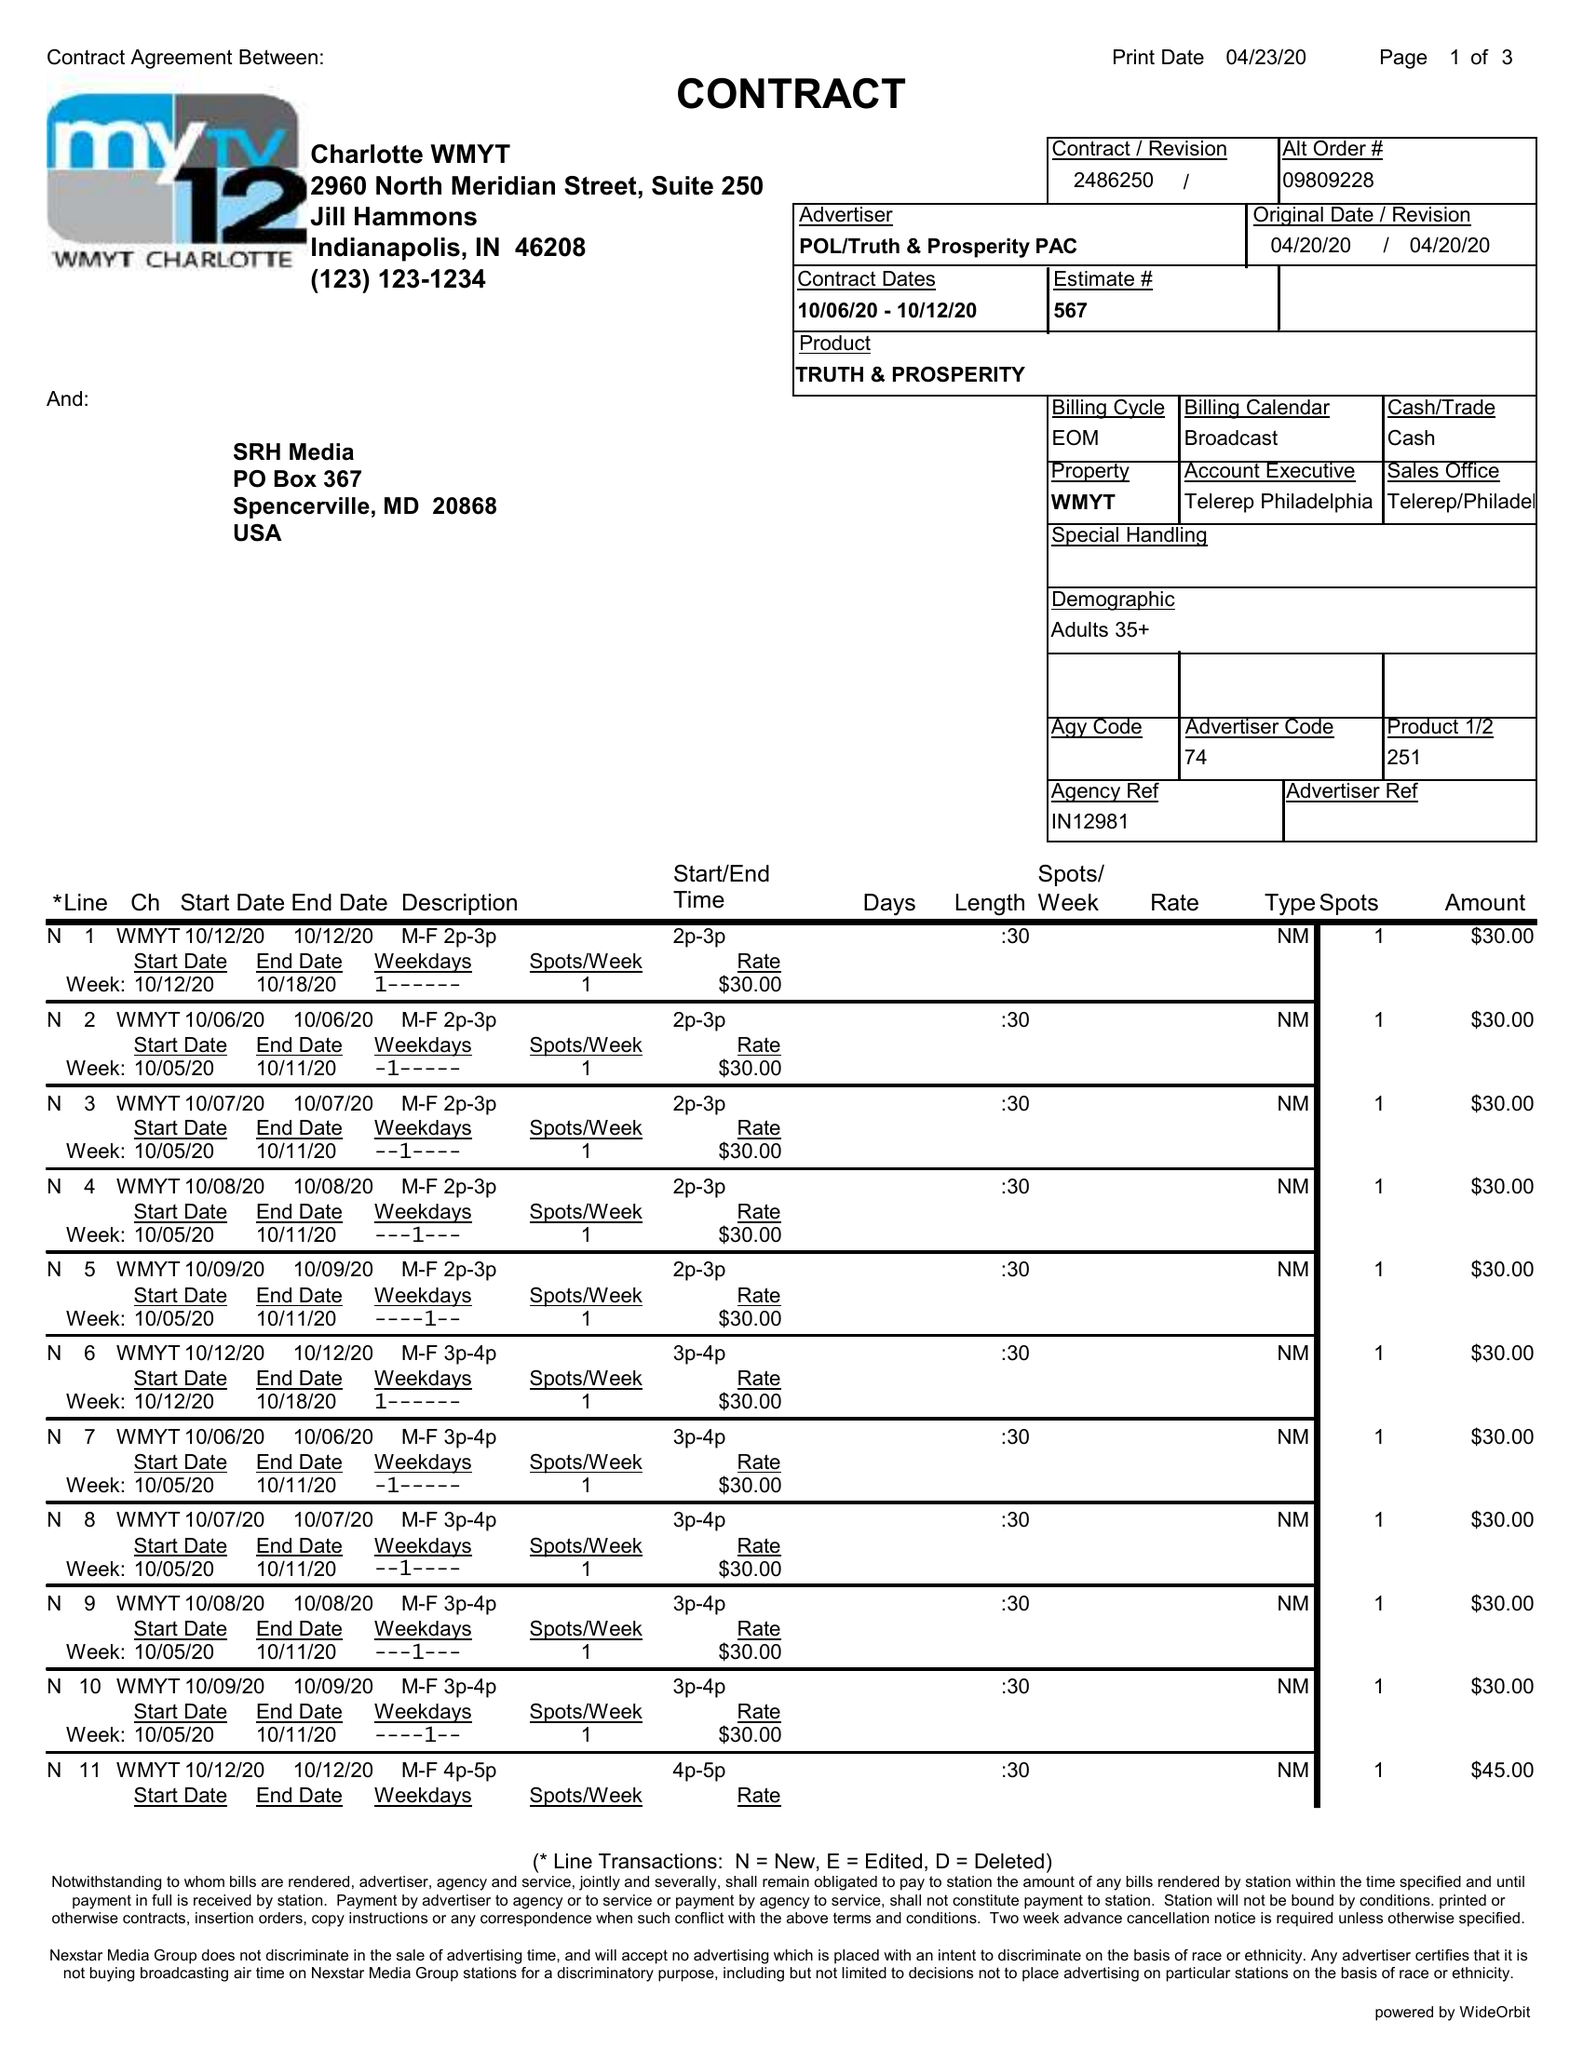What is the value for the flight_from?
Answer the question using a single word or phrase. 10/06/20 